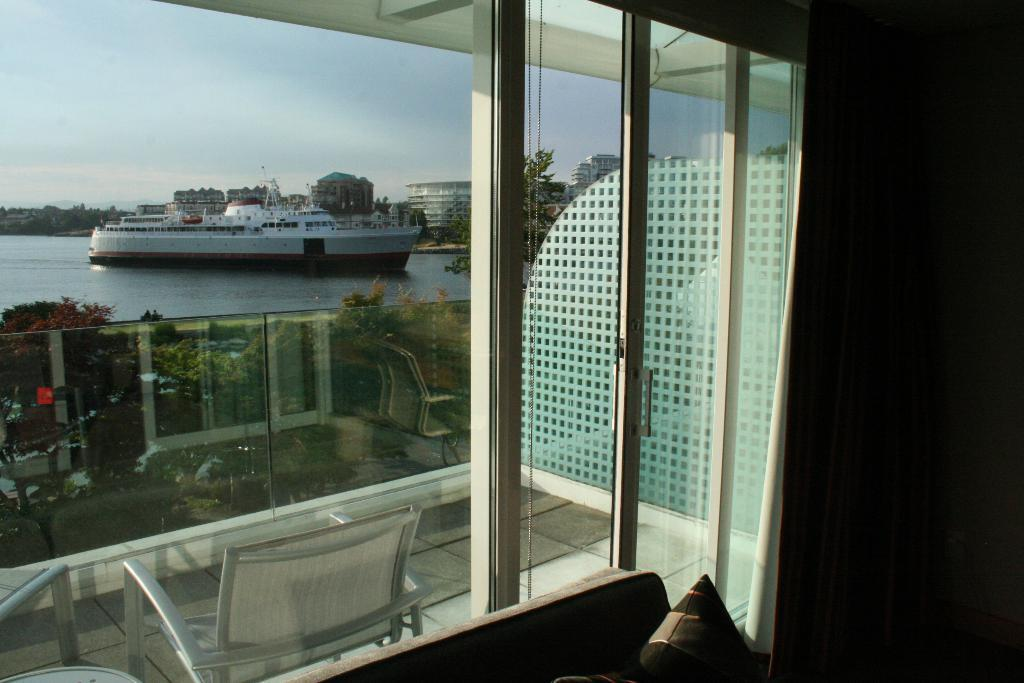What type of furniture is present in the image? There is a sofa with pillows in the image. What type of doors can be seen in the image? There are glass doors in the image. What is visible through the glass doors? A chair is visible through the glass doors. What type of vegetation is present in the image? There are plants in the image. What is floating on water in the image? There is a ship floating on water in the image. What can be seen in the background of the image? Buildings and the sky are visible in the background of the image. How many feet are visible on the sofa in the image? There are no feet visible on the sofa in the image. What type of shoes can be seen on the chair through the glass doors? There are no shoes present in the image. 